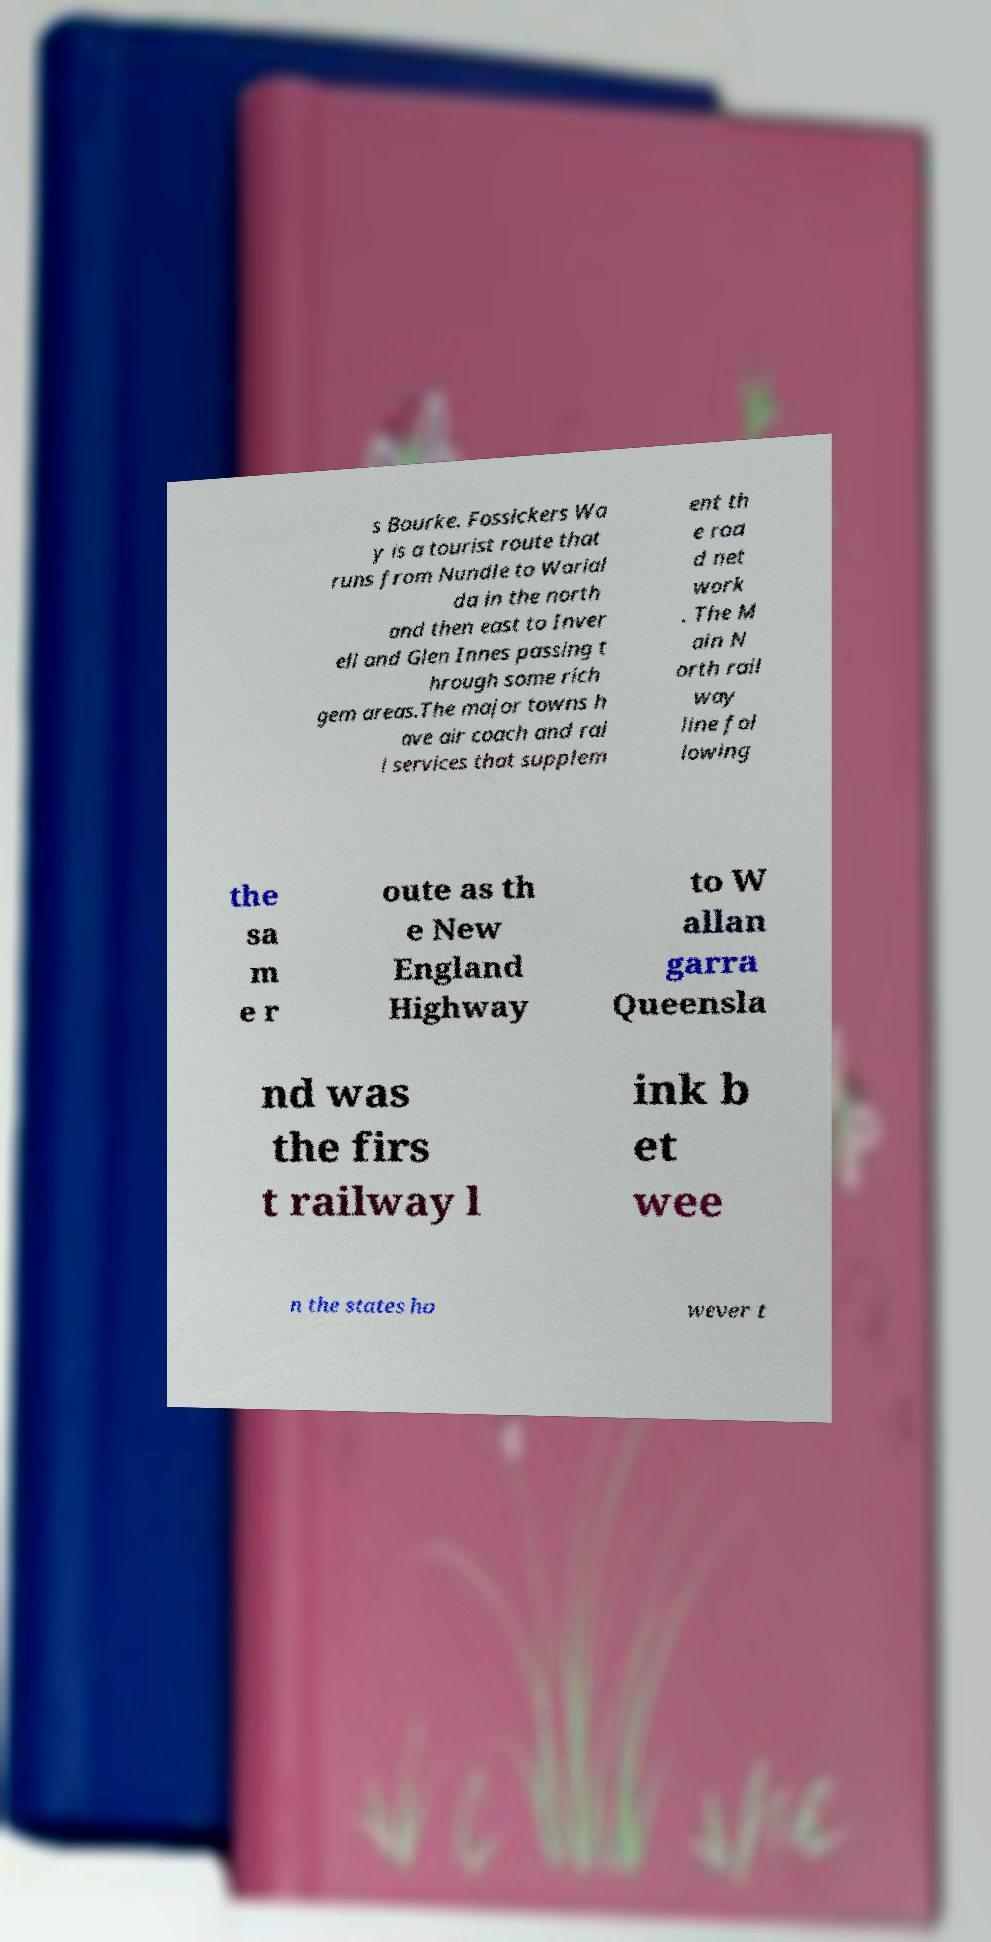Can you accurately transcribe the text from the provided image for me? s Bourke. Fossickers Wa y is a tourist route that runs from Nundle to Warial da in the north and then east to Inver ell and Glen Innes passing t hrough some rich gem areas.The major towns h ave air coach and rai l services that supplem ent th e roa d net work . The M ain N orth rail way line fol lowing the sa m e r oute as th e New England Highway to W allan garra Queensla nd was the firs t railway l ink b et wee n the states ho wever t 